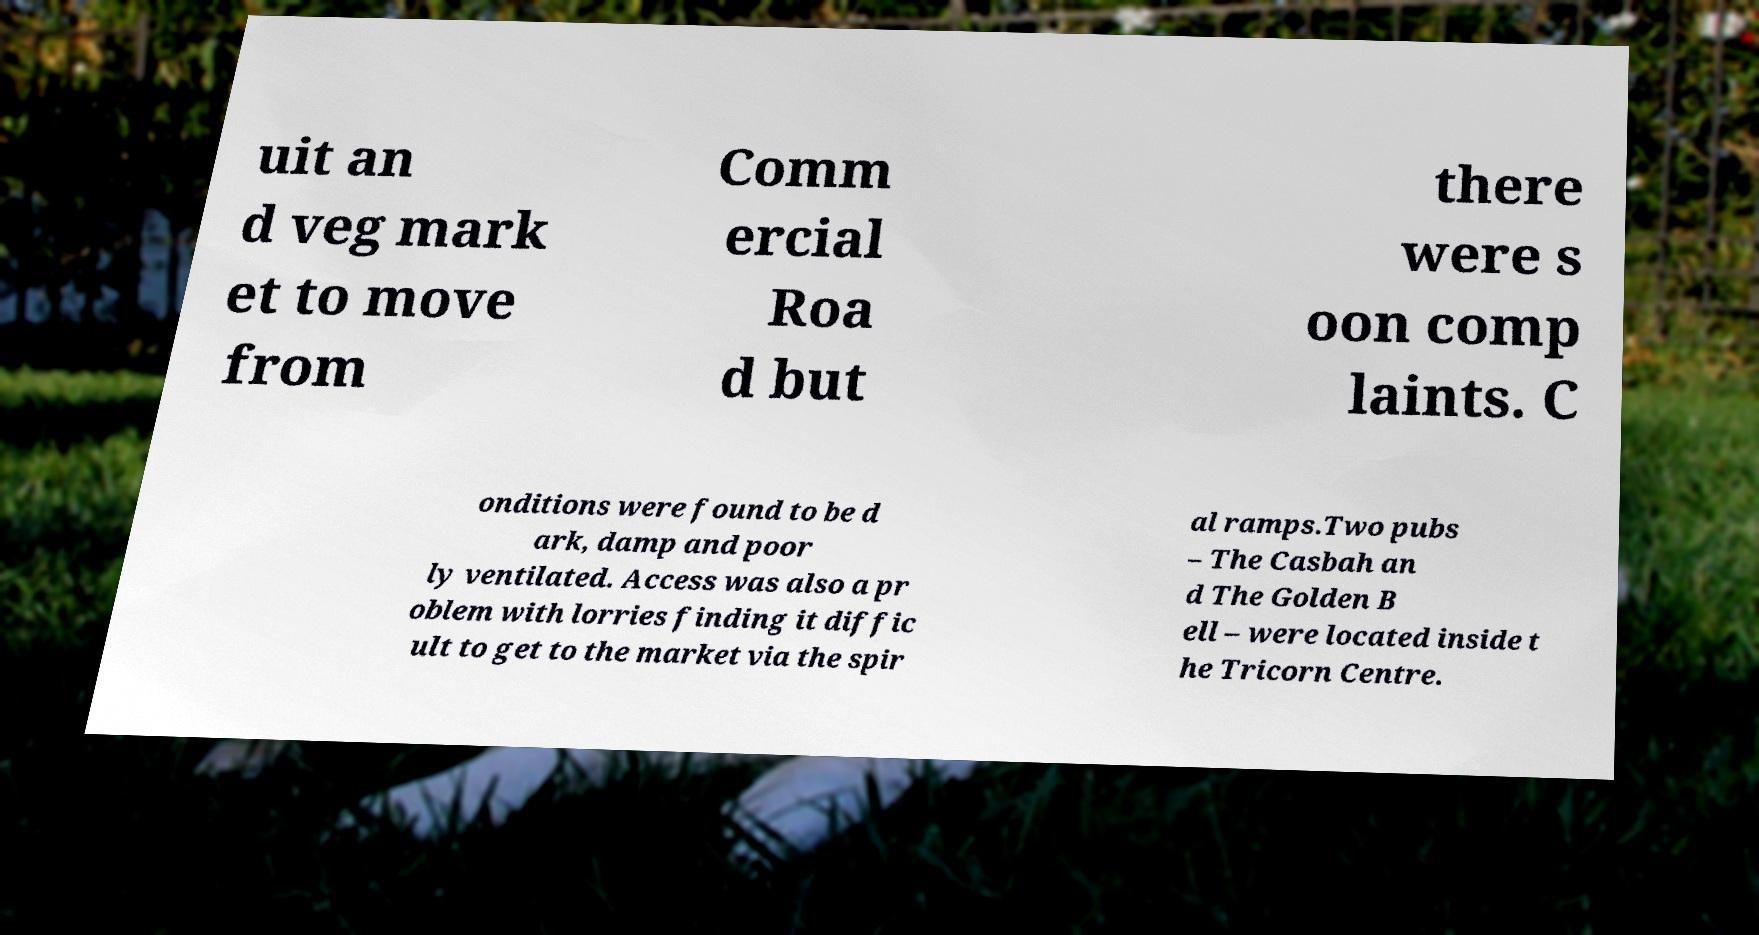Can you accurately transcribe the text from the provided image for me? uit an d veg mark et to move from Comm ercial Roa d but there were s oon comp laints. C onditions were found to be d ark, damp and poor ly ventilated. Access was also a pr oblem with lorries finding it diffic ult to get to the market via the spir al ramps.Two pubs – The Casbah an d The Golden B ell – were located inside t he Tricorn Centre. 